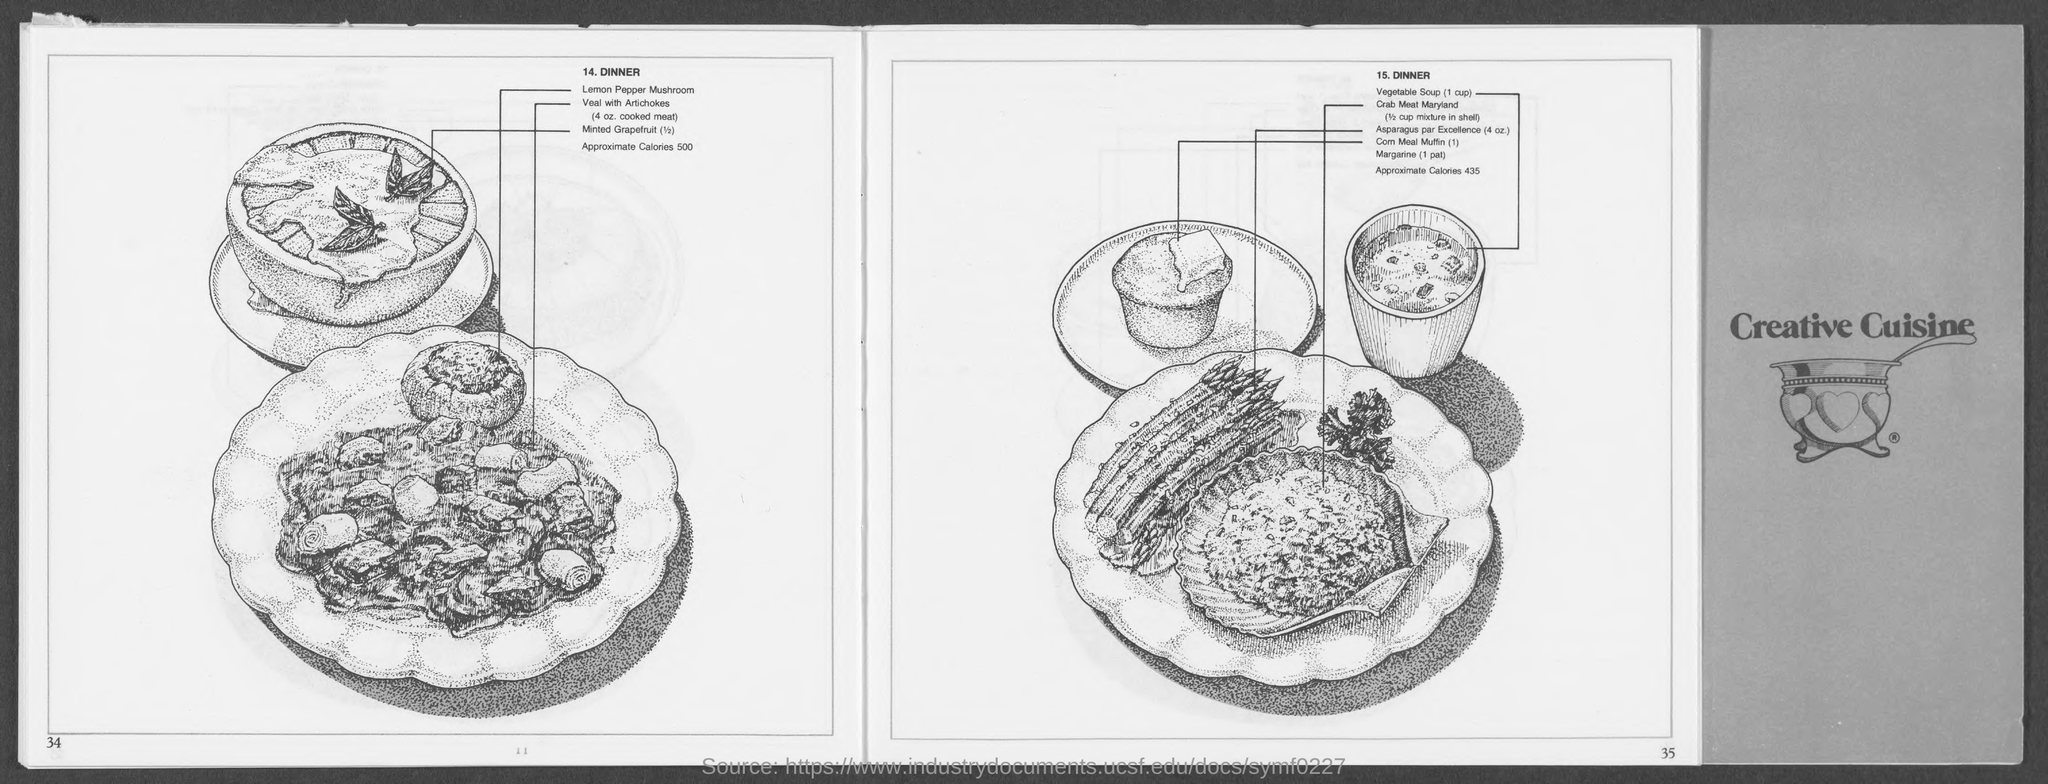How much amount of veal with artichokes is mentioned?
Make the answer very short. 4 oz. cooked meat. What is the name on the book cover?
Offer a terse response. CREATIVE CUISINE. 